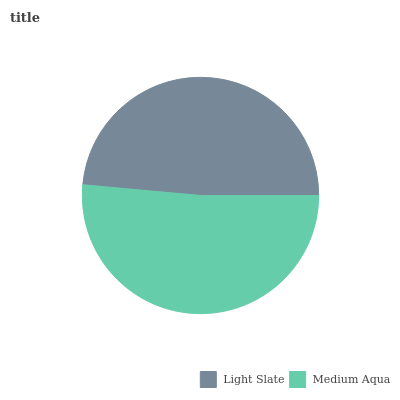Is Light Slate the minimum?
Answer yes or no. Yes. Is Medium Aqua the maximum?
Answer yes or no. Yes. Is Medium Aqua the minimum?
Answer yes or no. No. Is Medium Aqua greater than Light Slate?
Answer yes or no. Yes. Is Light Slate less than Medium Aqua?
Answer yes or no. Yes. Is Light Slate greater than Medium Aqua?
Answer yes or no. No. Is Medium Aqua less than Light Slate?
Answer yes or no. No. Is Medium Aqua the high median?
Answer yes or no. Yes. Is Light Slate the low median?
Answer yes or no. Yes. Is Light Slate the high median?
Answer yes or no. No. Is Medium Aqua the low median?
Answer yes or no. No. 